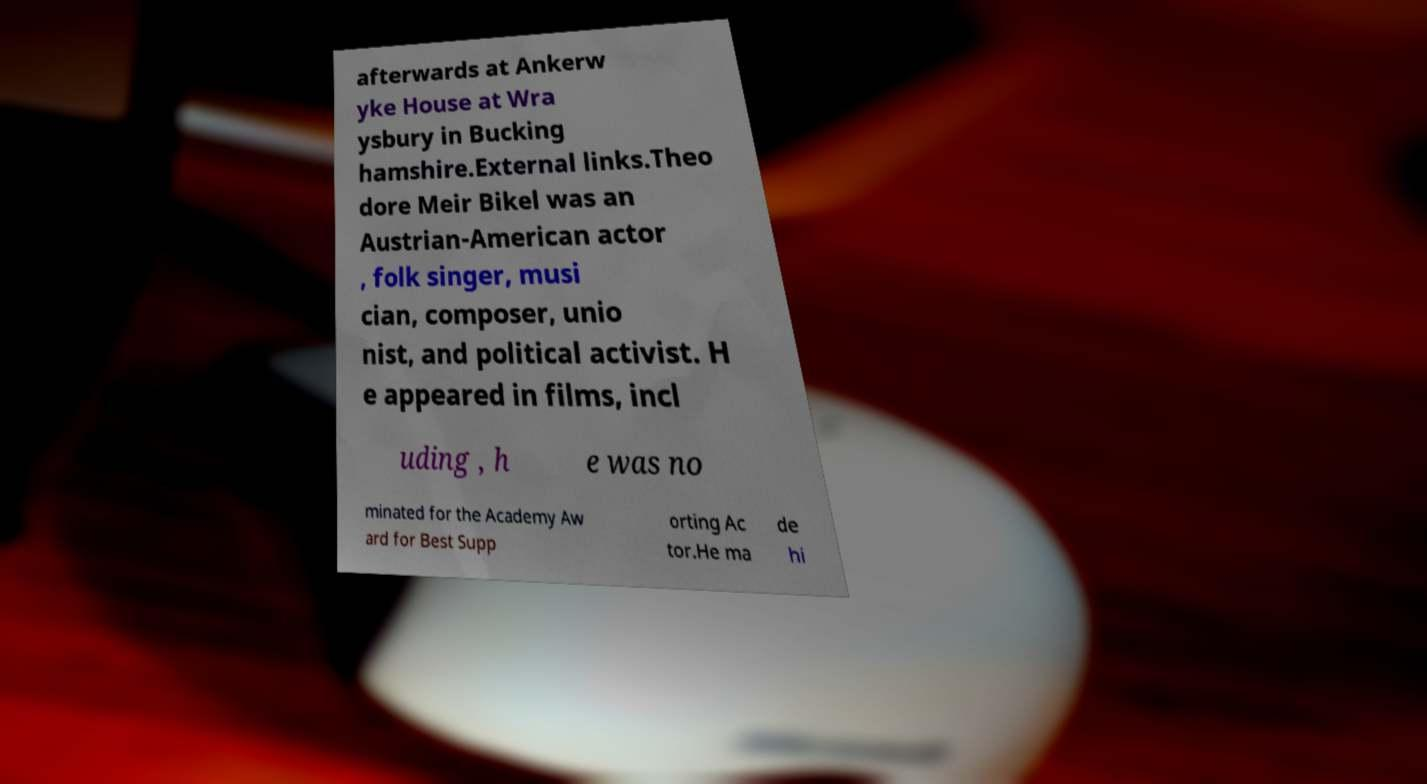Can you read and provide the text displayed in the image?This photo seems to have some interesting text. Can you extract and type it out for me? afterwards at Ankerw yke House at Wra ysbury in Bucking hamshire.External links.Theo dore Meir Bikel was an Austrian-American actor , folk singer, musi cian, composer, unio nist, and political activist. H e appeared in films, incl uding , h e was no minated for the Academy Aw ard for Best Supp orting Ac tor.He ma de hi 